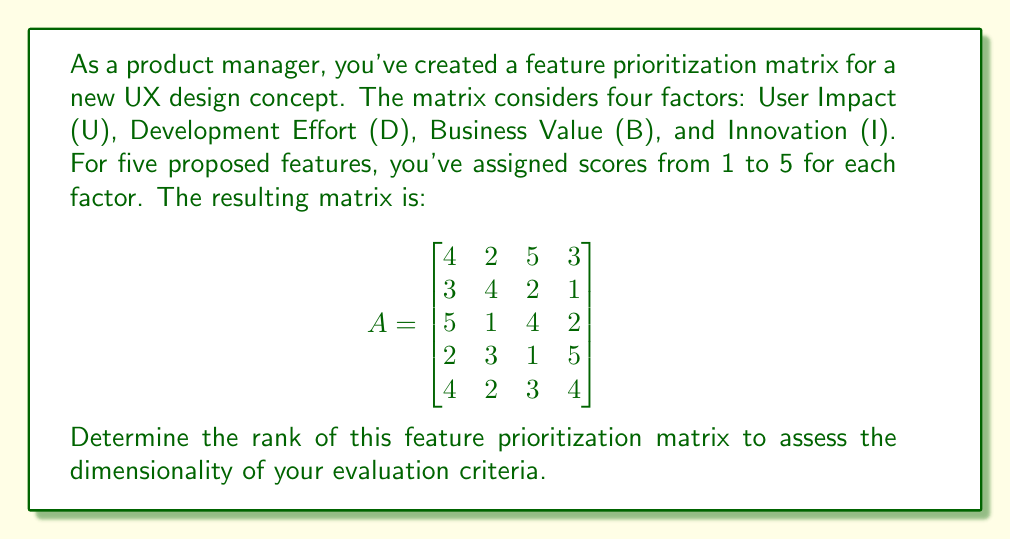Could you help me with this problem? To determine the rank of the matrix, we need to find the number of linearly independent rows or columns. We can do this by performing Gaussian elimination to obtain the row echelon form of the matrix.

Step 1: Write the augmented matrix
$$
\begin{bmatrix}
4 & 2 & 5 & 3 \\
3 & 4 & 2 & 1 \\
5 & 1 & 4 & 2 \\
2 & 3 & 1 & 5 \\
4 & 2 & 3 & 4
\end{bmatrix}
$$

Step 2: Use the first row as a pivot to eliminate elements below it
$$
\begin{bmatrix}
4 & 2 & 5 & 3 \\
0 & 3 & -\frac{7}{4} & -\frac{5}{4} \\
0 & -\frac{3}{4} & -\frac{9}{4} & -\frac{7}{4} \\
0 & 2 & -\frac{3}{2} & \frac{7}{2} \\
0 & 0 & -2 & 1
\end{bmatrix}
$$

Step 3: Use the second row as a pivot
$$
\begin{bmatrix}
4 & 2 & 5 & 3 \\
0 & 3 & -\frac{7}{4} & -\frac{5}{4} \\
0 & 0 & -\frac{3}{4} & -\frac{1}{4} \\
0 & 0 & \frac{1}{4} & \frac{25}{4} \\
0 & 0 & -2 & 1
\end{bmatrix}
$$

Step 4: Use the third row as a pivot
$$
\begin{bmatrix}
4 & 2 & 5 & 3 \\
0 & 3 & -\frac{7}{4} & -\frac{5}{4} \\
0 & 0 & -\frac{3}{4} & -\frac{1}{4} \\
0 & 0 & 0 & \frac{26}{3} \\
0 & 0 & 0 & \frac{5}{3}
\end{bmatrix}
$$

The matrix is now in row echelon form. The rank of the matrix is equal to the number of non-zero rows, which is 4.

This means that all four factors (User Impact, Development Effort, Business Value, and Innovation) contribute independently to the feature prioritization, providing a comprehensive evaluation framework for the UX design concepts.
Answer: 4 